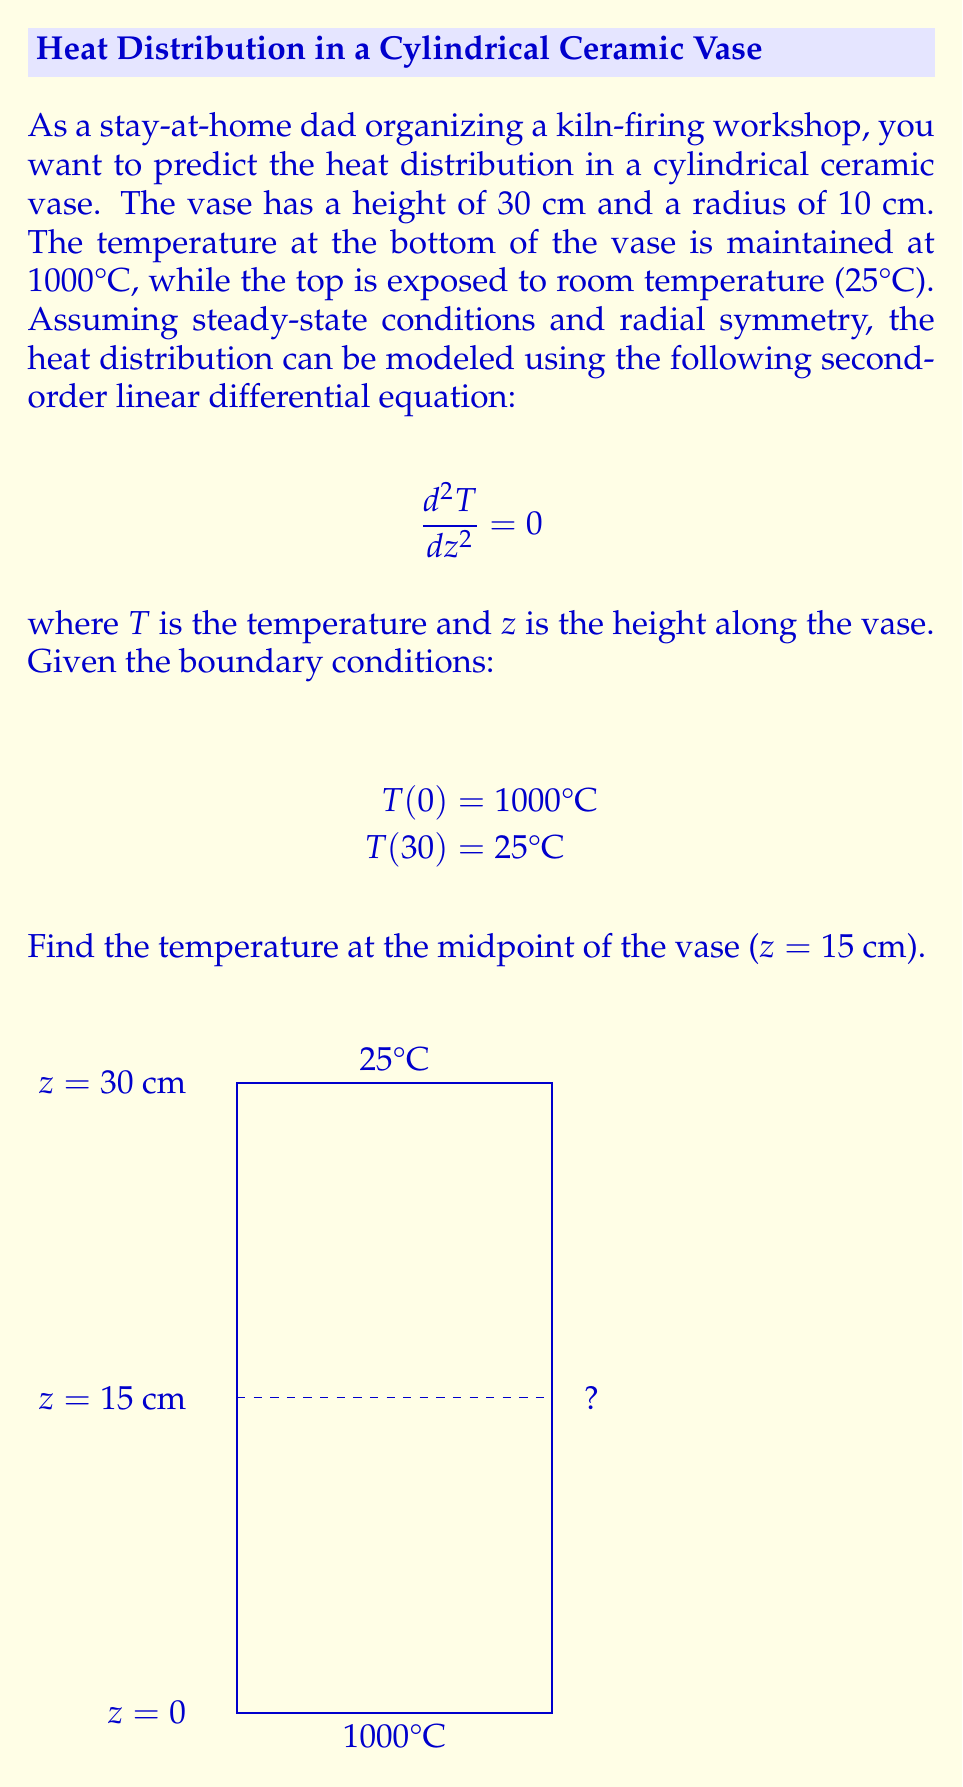Could you help me with this problem? To solve this problem, we'll follow these steps:

1) The general solution to the differential equation $\frac{d^2T}{dz^2} = 0$ is:

   $T(z) = Az + B$

   where $A$ and $B$ are constants we need to determine.

2) Apply the boundary conditions:
   At $z = 0$: $T(0) = B = 1000$
   At $z = 30$: $T(30) = 30A + 1000 = 25$

3) Solve for $A$:
   $30A + 1000 = 25$
   $30A = -975$
   $A = -32.5$

4) Our temperature distribution function is now:
   $T(z) = -32.5z + 1000$

5) To find the temperature at the midpoint (z = 15 cm):
   $T(15) = -32.5(15) + 1000$
   $T(15) = -487.5 + 1000 = 512.5$

Therefore, the temperature at the midpoint of the vase is 512.5°C.
Answer: 512.5°C 